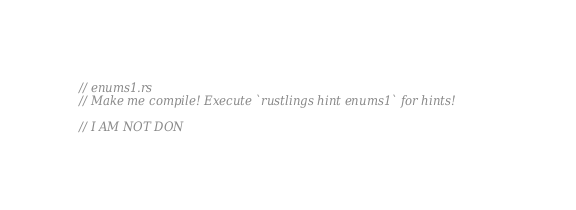Convert code to text. <code><loc_0><loc_0><loc_500><loc_500><_Rust_>// enums1.rs
// Make me compile! Execute `rustlings hint enums1` for hints!

// I AM NOT DON
</code> 